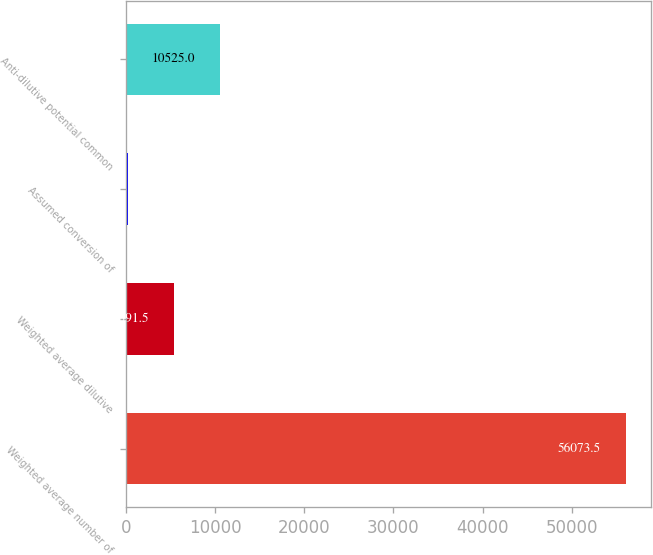Convert chart. <chart><loc_0><loc_0><loc_500><loc_500><bar_chart><fcel>Weighted average number of<fcel>Weighted average dilutive<fcel>Assumed conversion of<fcel>Anti-dilutive potential common<nl><fcel>56073.5<fcel>5391.5<fcel>258<fcel>10525<nl></chart> 